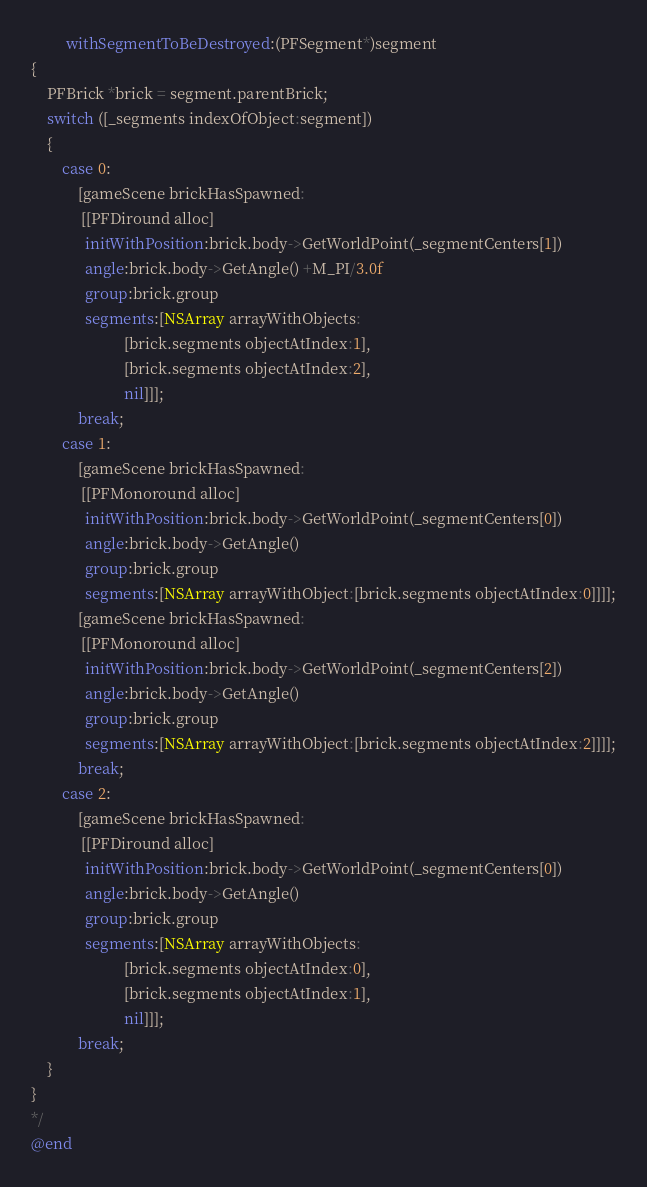Convert code to text. <code><loc_0><loc_0><loc_500><loc_500><_ObjectiveC_>         withSegmentToBeDestroyed:(PFSegment*)segment
{
    PFBrick *brick = segment.parentBrick;
    switch ([_segments indexOfObject:segment])
    {
        case 0:
            [gameScene brickHasSpawned:
             [[PFDiround alloc]
              initWithPosition:brick.body->GetWorldPoint(_segmentCenters[1])
              angle:brick.body->GetAngle() +M_PI/3.0f
              group:brick.group
              segments:[NSArray arrayWithObjects:
                        [brick.segments objectAtIndex:1],
                        [brick.segments objectAtIndex:2],
                        nil]]];
            break;
        case 1:
            [gameScene brickHasSpawned:
             [[PFMonoround alloc]
              initWithPosition:brick.body->GetWorldPoint(_segmentCenters[0])
              angle:brick.body->GetAngle()
              group:brick.group
              segments:[NSArray arrayWithObject:[brick.segments objectAtIndex:0]]]];
            [gameScene brickHasSpawned:
             [[PFMonoround alloc]
              initWithPosition:brick.body->GetWorldPoint(_segmentCenters[2])
              angle:brick.body->GetAngle()
              group:brick.group
              segments:[NSArray arrayWithObject:[brick.segments objectAtIndex:2]]]];
            break;
        case 2:
            [gameScene brickHasSpawned:
             [[PFDiround alloc]
              initWithPosition:brick.body->GetWorldPoint(_segmentCenters[0])
              angle:brick.body->GetAngle()
              group:brick.group
              segments:[NSArray arrayWithObjects:
                        [brick.segments objectAtIndex:0],
                        [brick.segments objectAtIndex:1],
                        nil]]];
            break;
    }
}
*/
@end
</code> 